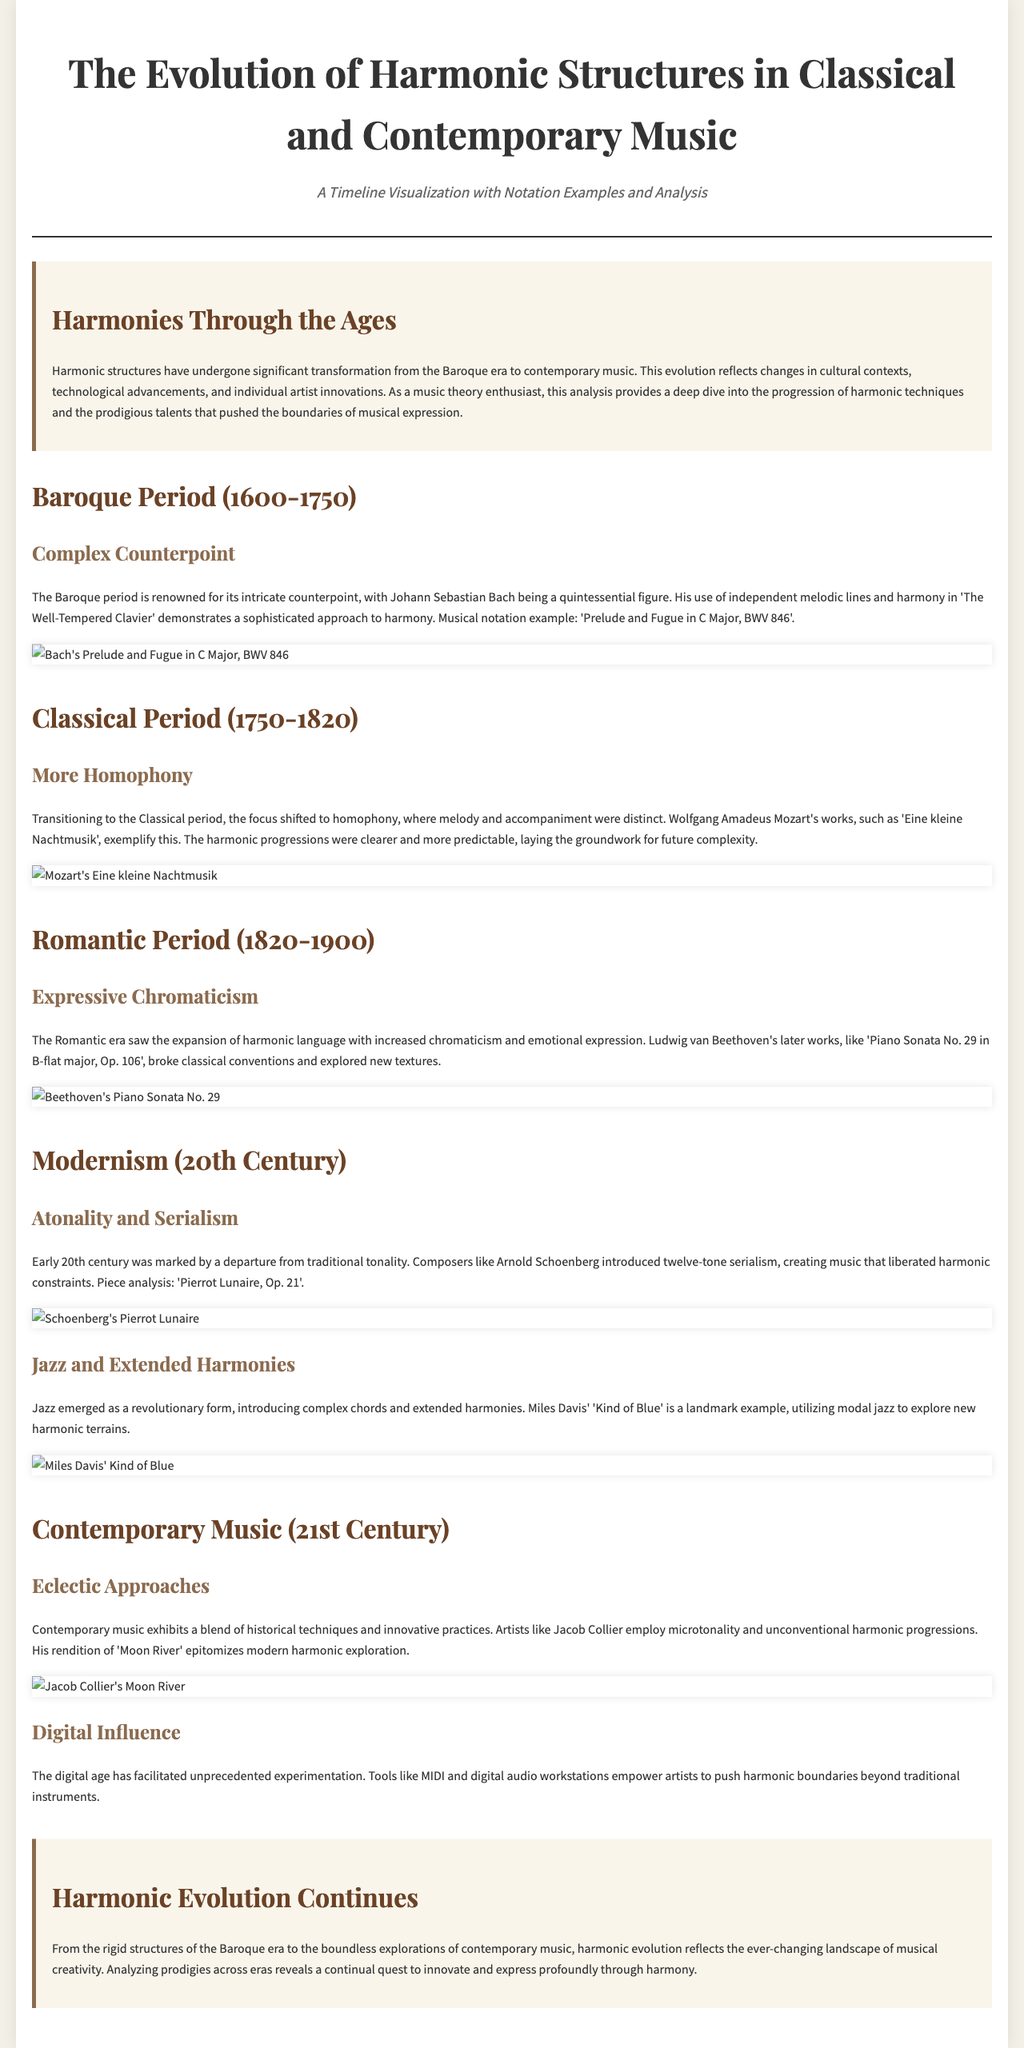What is the end year of the Classical period? The document specifies that the Classical period is from 1750 to 1820, which means the end year is 1820.
Answer: 1820 Who is a quintessential figure of the Baroque period? The document identifies Johann Sebastian Bach as a quintessential figure of the Baroque period.
Answer: Johann Sebastian Bach What harmonic technique is emphasized in the Classical Period? The focus in the Classical period is mentioned as homophony, where melody and accompaniment are distinct.
Answer: Homophony Which composer introduced twelve-tone serialism? The document states that Arnold Schoenberg introduced twelve-tone serialism in the early 20th century.
Answer: Arnold Schoenberg What is a landmark example of jazz music mentioned in the document? The document refers to Miles Davis' 'Kind of Blue' as a landmark example of jazz music.
Answer: Kind of Blue What year does the contemporary music section refer to? The section on Contemporary Music discusses the 21st century and its developments.
Answer: 21st Century Which harmonic exploration does Jacob Collier's rendition of 'Moon River' epitomize? The document states that Collier's rendition epitomizes modern harmonic exploration.
Answer: Modern harmonic exploration What significant change occurred during the Romantic Period in harmonic language? The document notes that the Romantic era saw an expansion of harmonic language, notably through increased chromaticism.
Answer: Chromaticism What technological development impacts contemporary music according to the document? The document mentions that digital audio workstations empower artists to push harmonic boundaries.
Answer: Digital audio workstations 